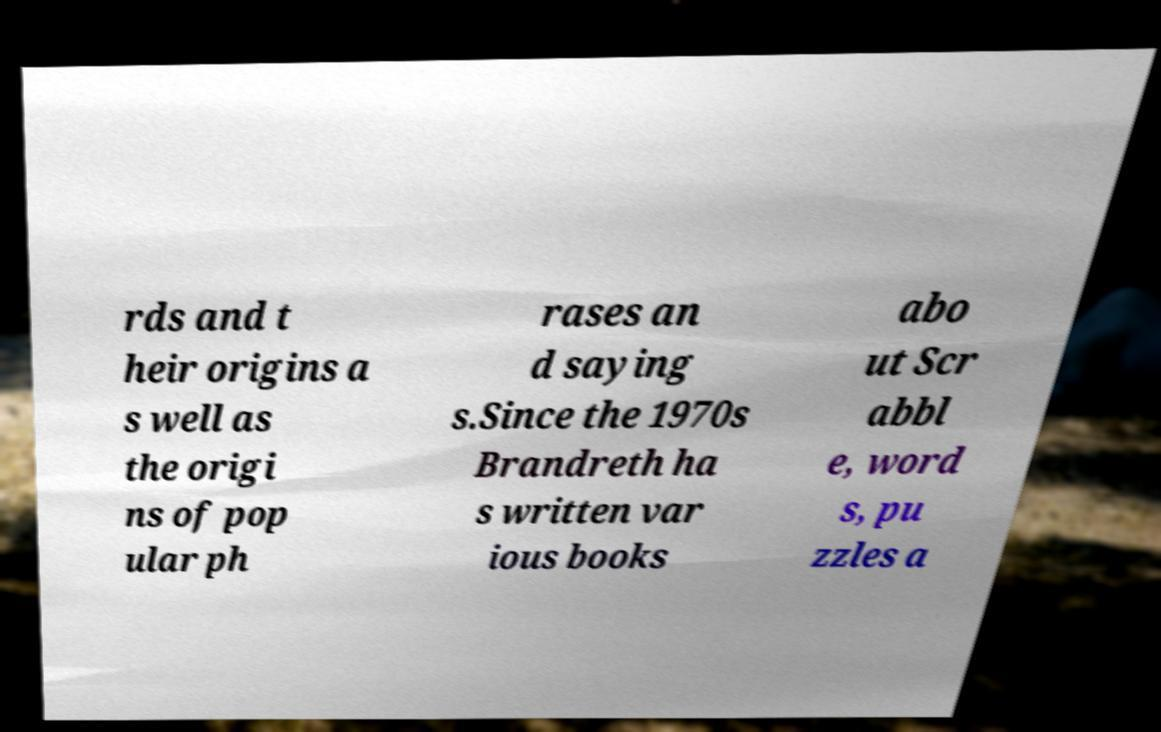I need the written content from this picture converted into text. Can you do that? rds and t heir origins a s well as the origi ns of pop ular ph rases an d saying s.Since the 1970s Brandreth ha s written var ious books abo ut Scr abbl e, word s, pu zzles a 